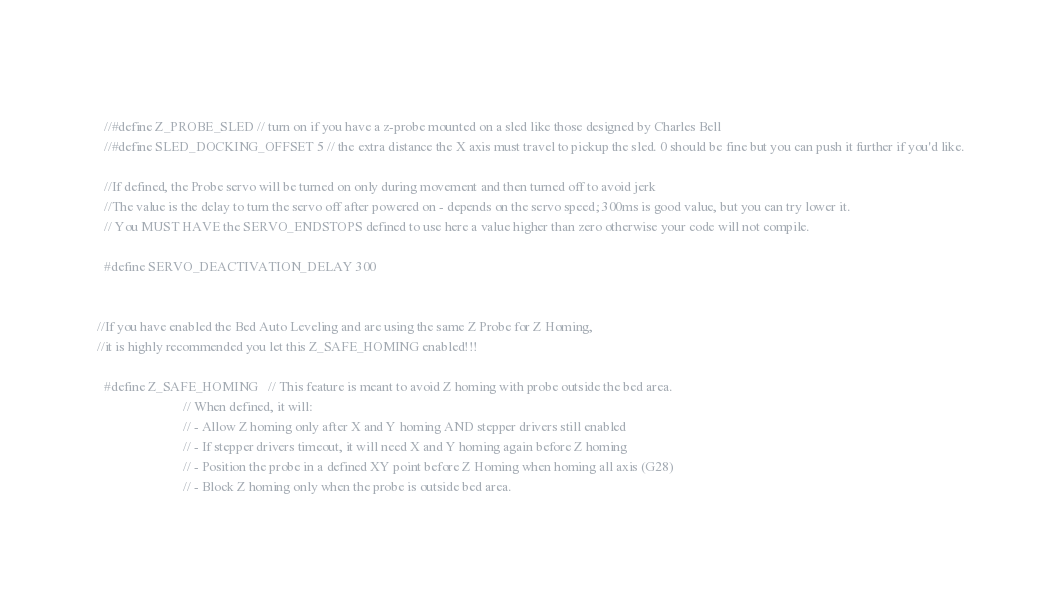Convert code to text. <code><loc_0><loc_0><loc_500><loc_500><_C_>                                                                           
  //#define Z_PROBE_SLED // turn on if you have a z-probe mounted on a sled like those designed by Charles Bell
  //#define SLED_DOCKING_OFFSET 5 // the extra distance the X axis must travel to pickup the sled. 0 should be fine but you can push it further if you'd like.

  //If defined, the Probe servo will be turned on only during movement and then turned off to avoid jerk
  //The value is the delay to turn the servo off after powered on - depends on the servo speed; 300ms is good value, but you can try lower it.
  // You MUST HAVE the SERVO_ENDSTOPS defined to use here a value higher than zero otherwise your code will not compile.

  #define SERVO_DEACTIVATION_DELAY 300


//If you have enabled the Bed Auto Leveling and are using the same Z Probe for Z Homing,
//it is highly recommended you let this Z_SAFE_HOMING enabled!!!

  #define Z_SAFE_HOMING   // This feature is meant to avoid Z homing with probe outside the bed area.
                          // When defined, it will:
                          // - Allow Z homing only after X and Y homing AND stepper drivers still enabled
                          // - If stepper drivers timeout, it will need X and Y homing again before Z homing
                          // - Position the probe in a defined XY point before Z Homing when homing all axis (G28)
                          // - Block Z homing only when the probe is outside bed area.
</code> 